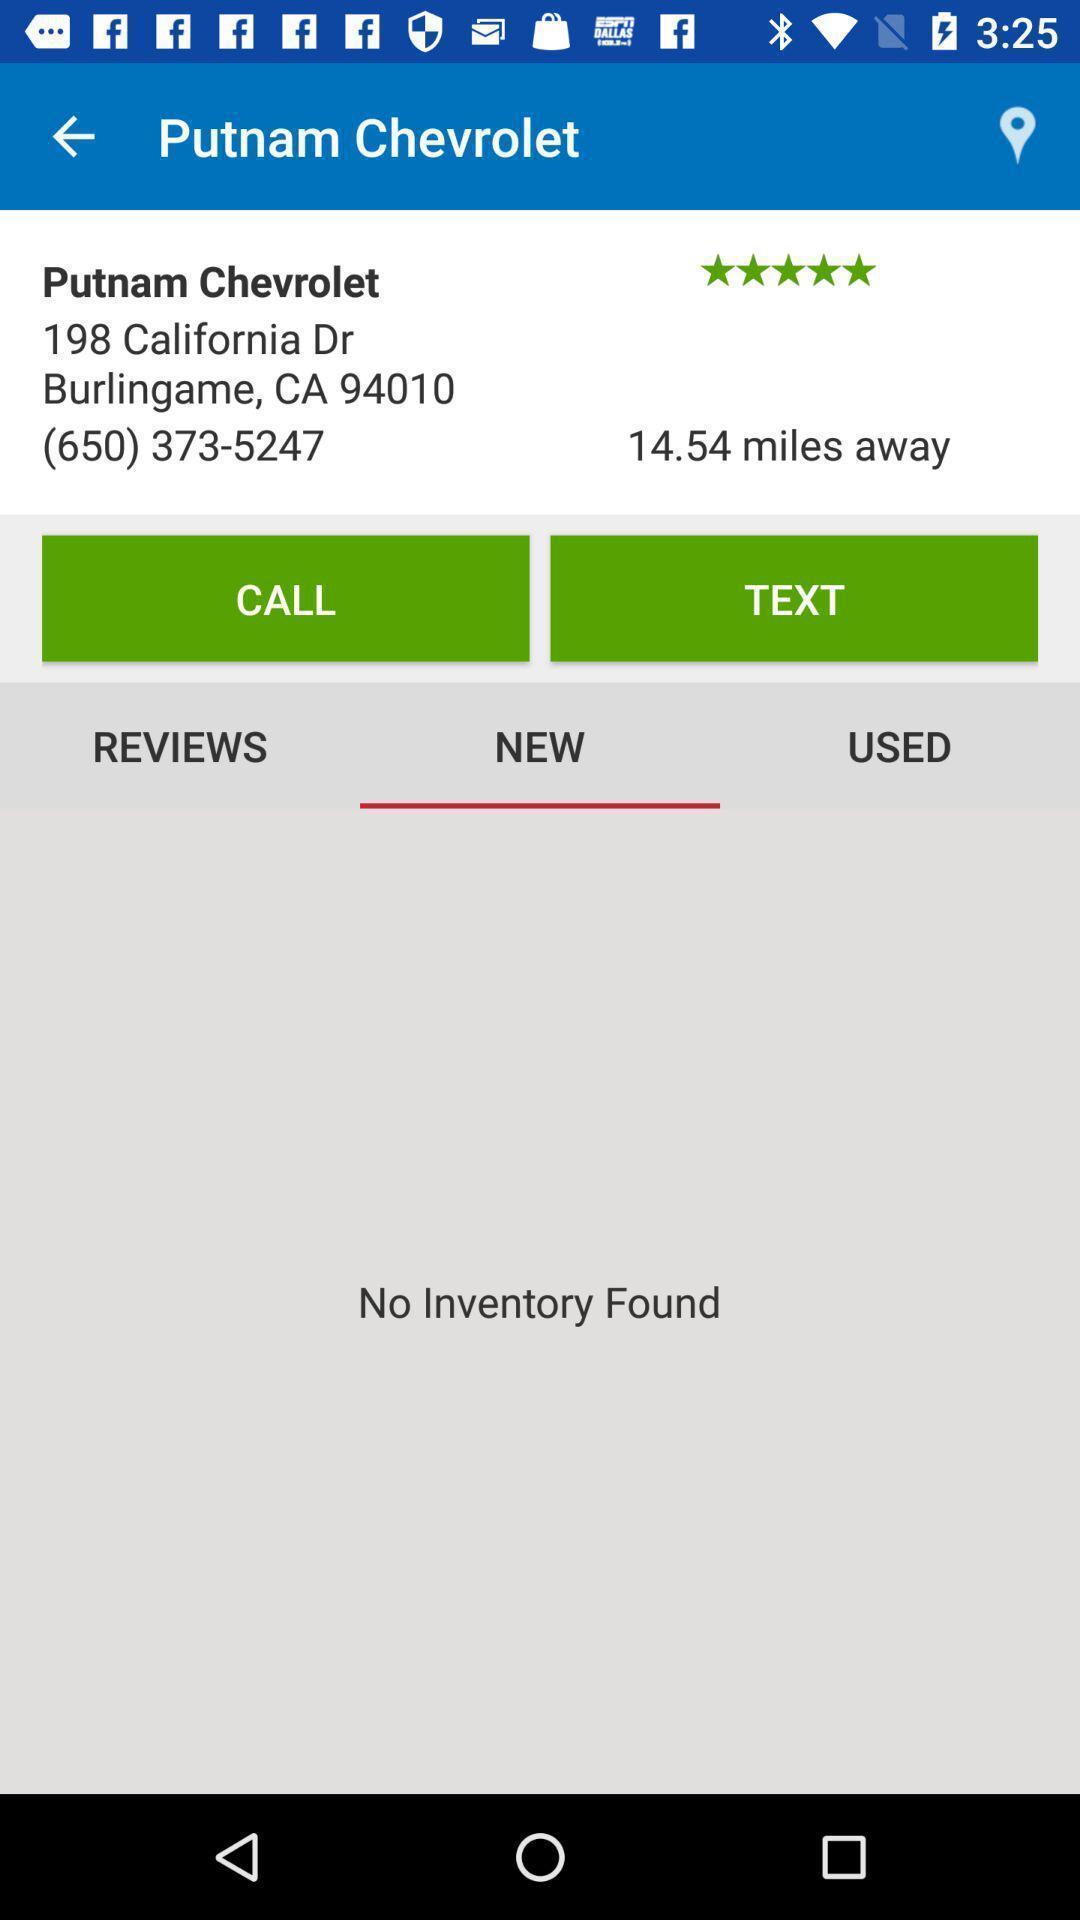Provide a textual representation of this image. Vehicles sales app rating showing in this page. 